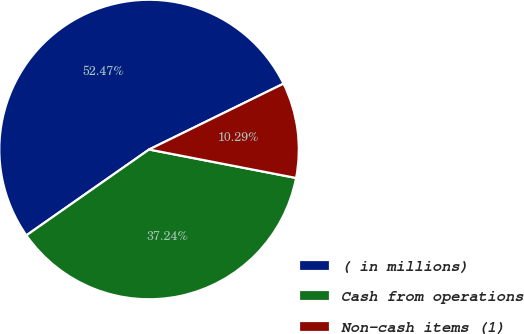Convert chart to OTSL. <chart><loc_0><loc_0><loc_500><loc_500><pie_chart><fcel>( in millions)<fcel>Cash from operations<fcel>Non-cash items (1)<nl><fcel>52.47%<fcel>37.24%<fcel>10.29%<nl></chart> 